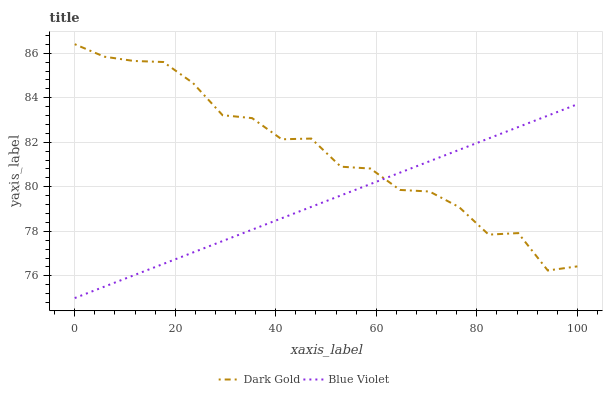Does Blue Violet have the minimum area under the curve?
Answer yes or no. Yes. Does Dark Gold have the maximum area under the curve?
Answer yes or no. Yes. Does Dark Gold have the minimum area under the curve?
Answer yes or no. No. Is Blue Violet the smoothest?
Answer yes or no. Yes. Is Dark Gold the roughest?
Answer yes or no. Yes. Is Dark Gold the smoothest?
Answer yes or no. No. Does Dark Gold have the lowest value?
Answer yes or no. No. Does Dark Gold have the highest value?
Answer yes or no. Yes. Does Blue Violet intersect Dark Gold?
Answer yes or no. Yes. Is Blue Violet less than Dark Gold?
Answer yes or no. No. Is Blue Violet greater than Dark Gold?
Answer yes or no. No. 